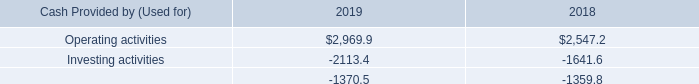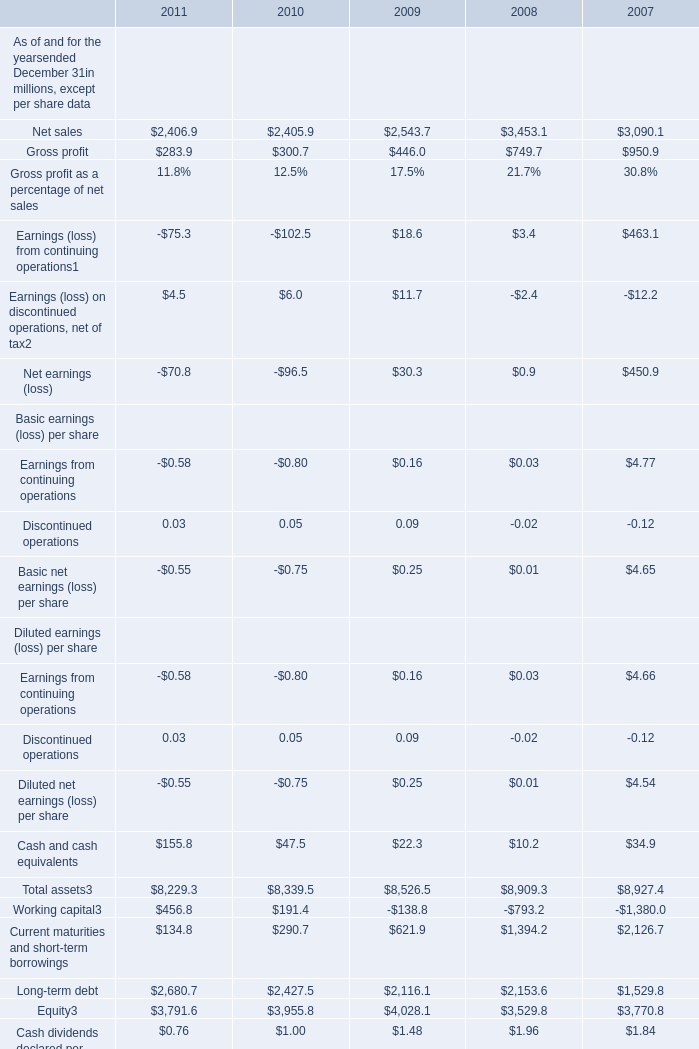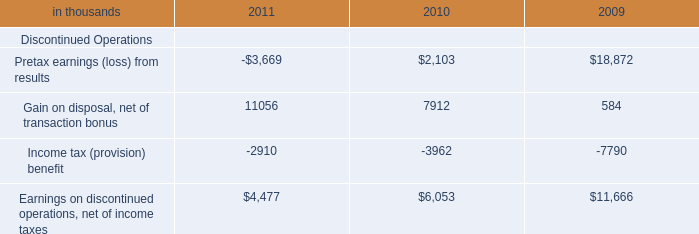considering the year 2018 , what is the cash flow result? 
Computations: ((2547.2 - 1641.6) - 1359.8)
Answer: -454.2. 